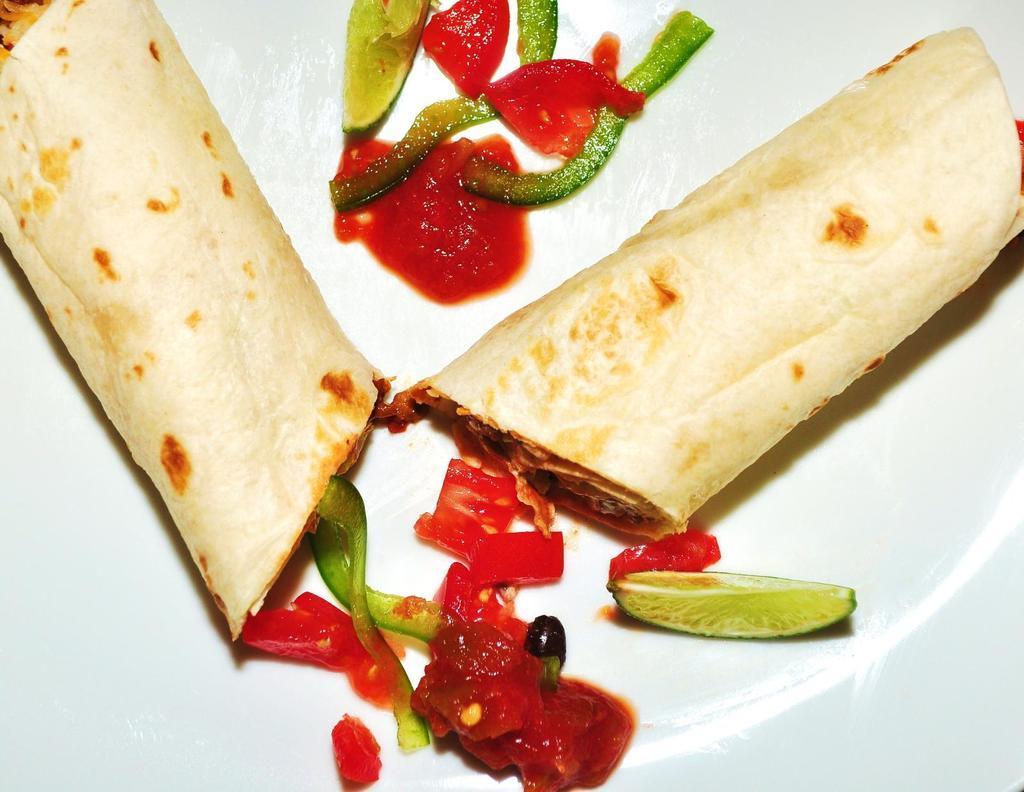How would you summarize this image in a sentence or two? In this image we can see food placed on the plate. 